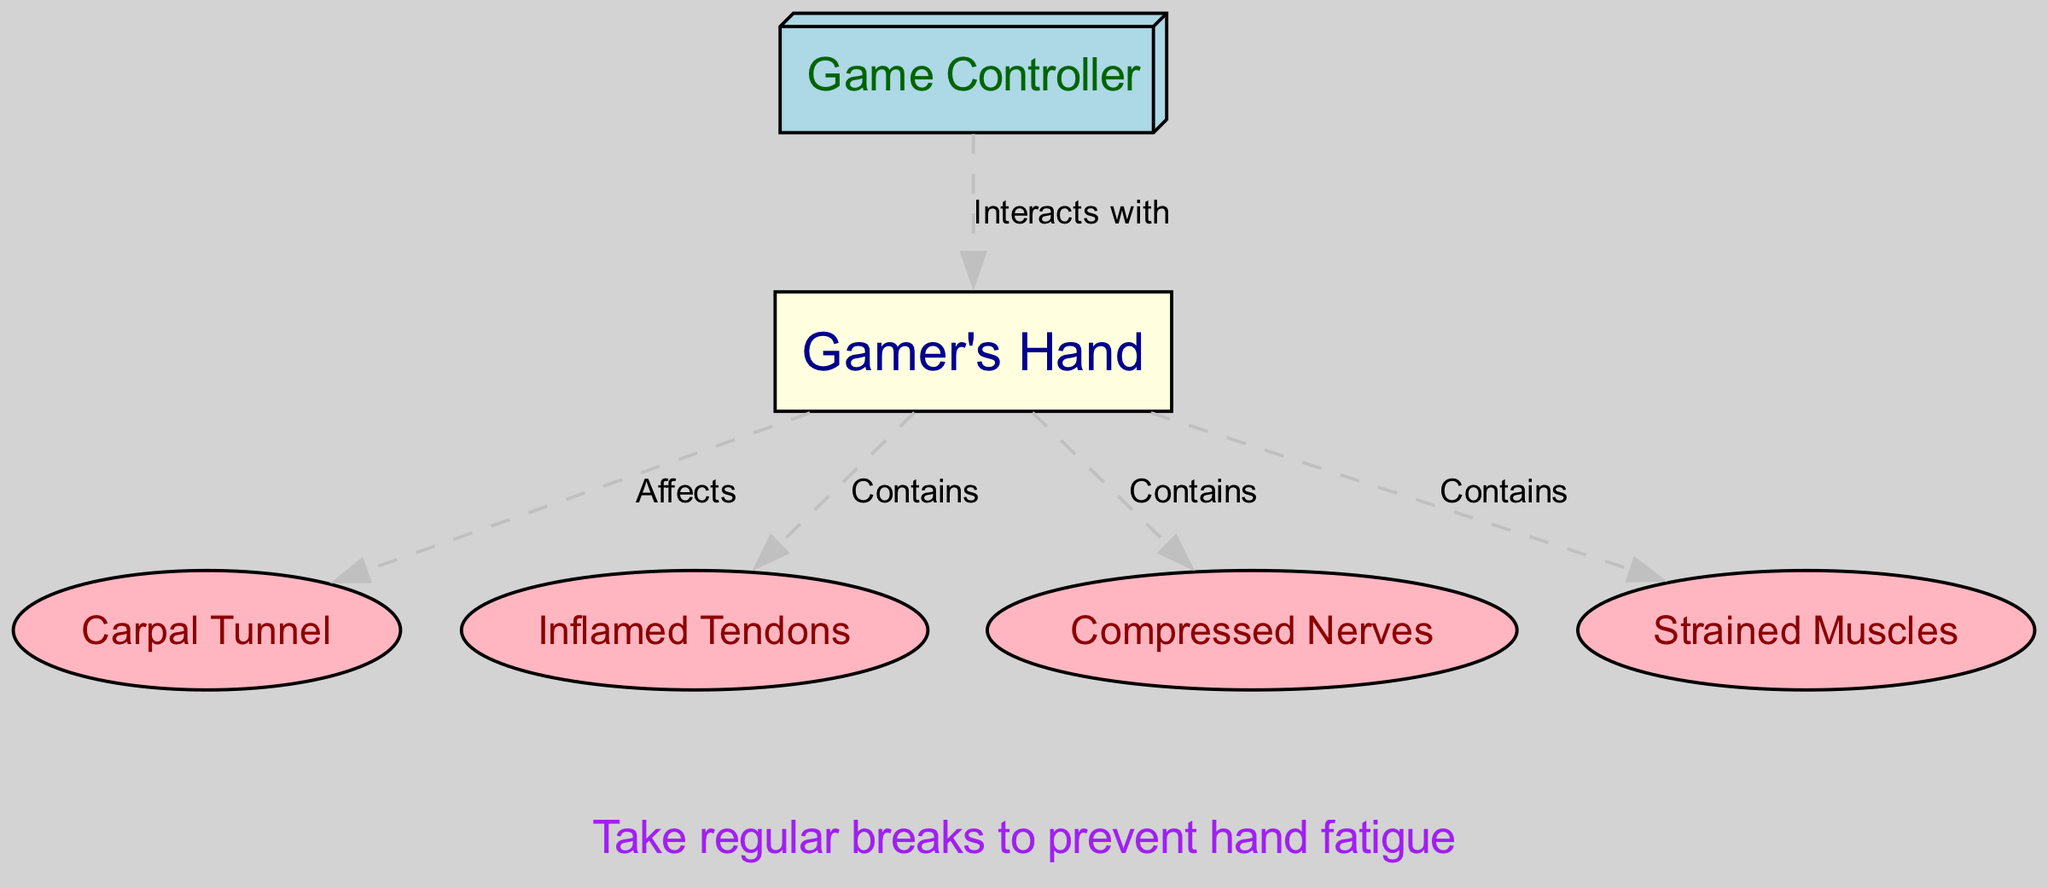What node represents the primary subject of the diagram? The diagram identifies "Gamer's Hand" as the primary subject through the labeled node "Gamer's Hand."
Answer: Gamer's Hand How many nodes are present in the diagram? By counting all unique labeled nodes in the diagram, we find there are six nodes: Gamer's Hand, Carpal Tunnel, Inflamed Tendons, Compressed Nerves, Strained Muscles, and Game Controller.
Answer: 6 What relationship exists between the game controller and the gamer's hand? The diagram shows an edge labeled "Interacts with" that describes how the Game Controller has a direct interaction with the Gamer's Hand.
Answer: Interacts with Which node affects the carpal tunnel? The diagram indicates that the Gamer's Hand node has an edge labeled "Affects," leading to the Carpal Tunnel node, highlighting that the hand can have an impact on this area.
Answer: Gamer's Hand What is a possible outcome of prolonged gaming sessions? According to the annotation in the diagram, prolonged gaming sessions can lead to "repetitive strain injuries," indicating a health consequence of excessive gameplay.
Answer: Repetitive strain injuries How are the nerves affected in the gamer's hand? The diagram shows that the hand "Contains" the Compressed Nerves node, indicating that due to certain conditions (like prolonged gaming), the nerves in the hand can be subjected to compression.
Answer: Compressed Nerves What should be done to prevent hand fatigue according to the diagram? The second annotation suggests taking "regular breaks" as a preventive measure against the development of hand fatigue during gaming activity.
Answer: Regular breaks Which components are contained in the gamer's hand? The diagram mentions that the Gamer's Hand "Contains" four components: Inflamed Tendons, Compressed Nerves, Strained Muscles, and the Carpal Tunnel.
Answer: Inflamed Tendons, Compressed Nerves, Strained Muscles, and Carpal Tunnel What color represents the gamer's hand on the diagram? The node for the Gamer's Hand is filled in light yellow, distinguishing it from other elements in the diagram.
Answer: Light yellow 